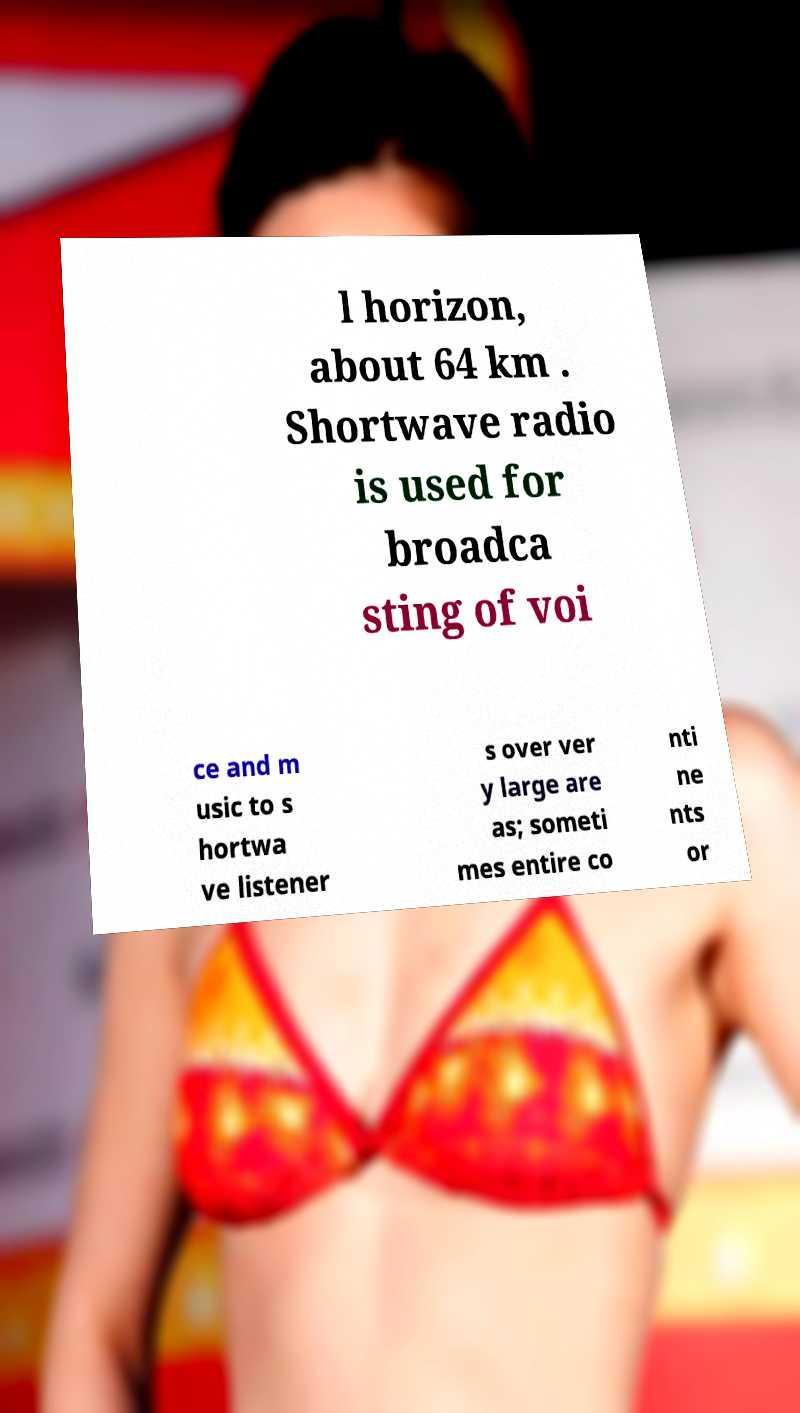Please read and relay the text visible in this image. What does it say? l horizon, about 64 km . Shortwave radio is used for broadca sting of voi ce and m usic to s hortwa ve listener s over ver y large are as; someti mes entire co nti ne nts or 